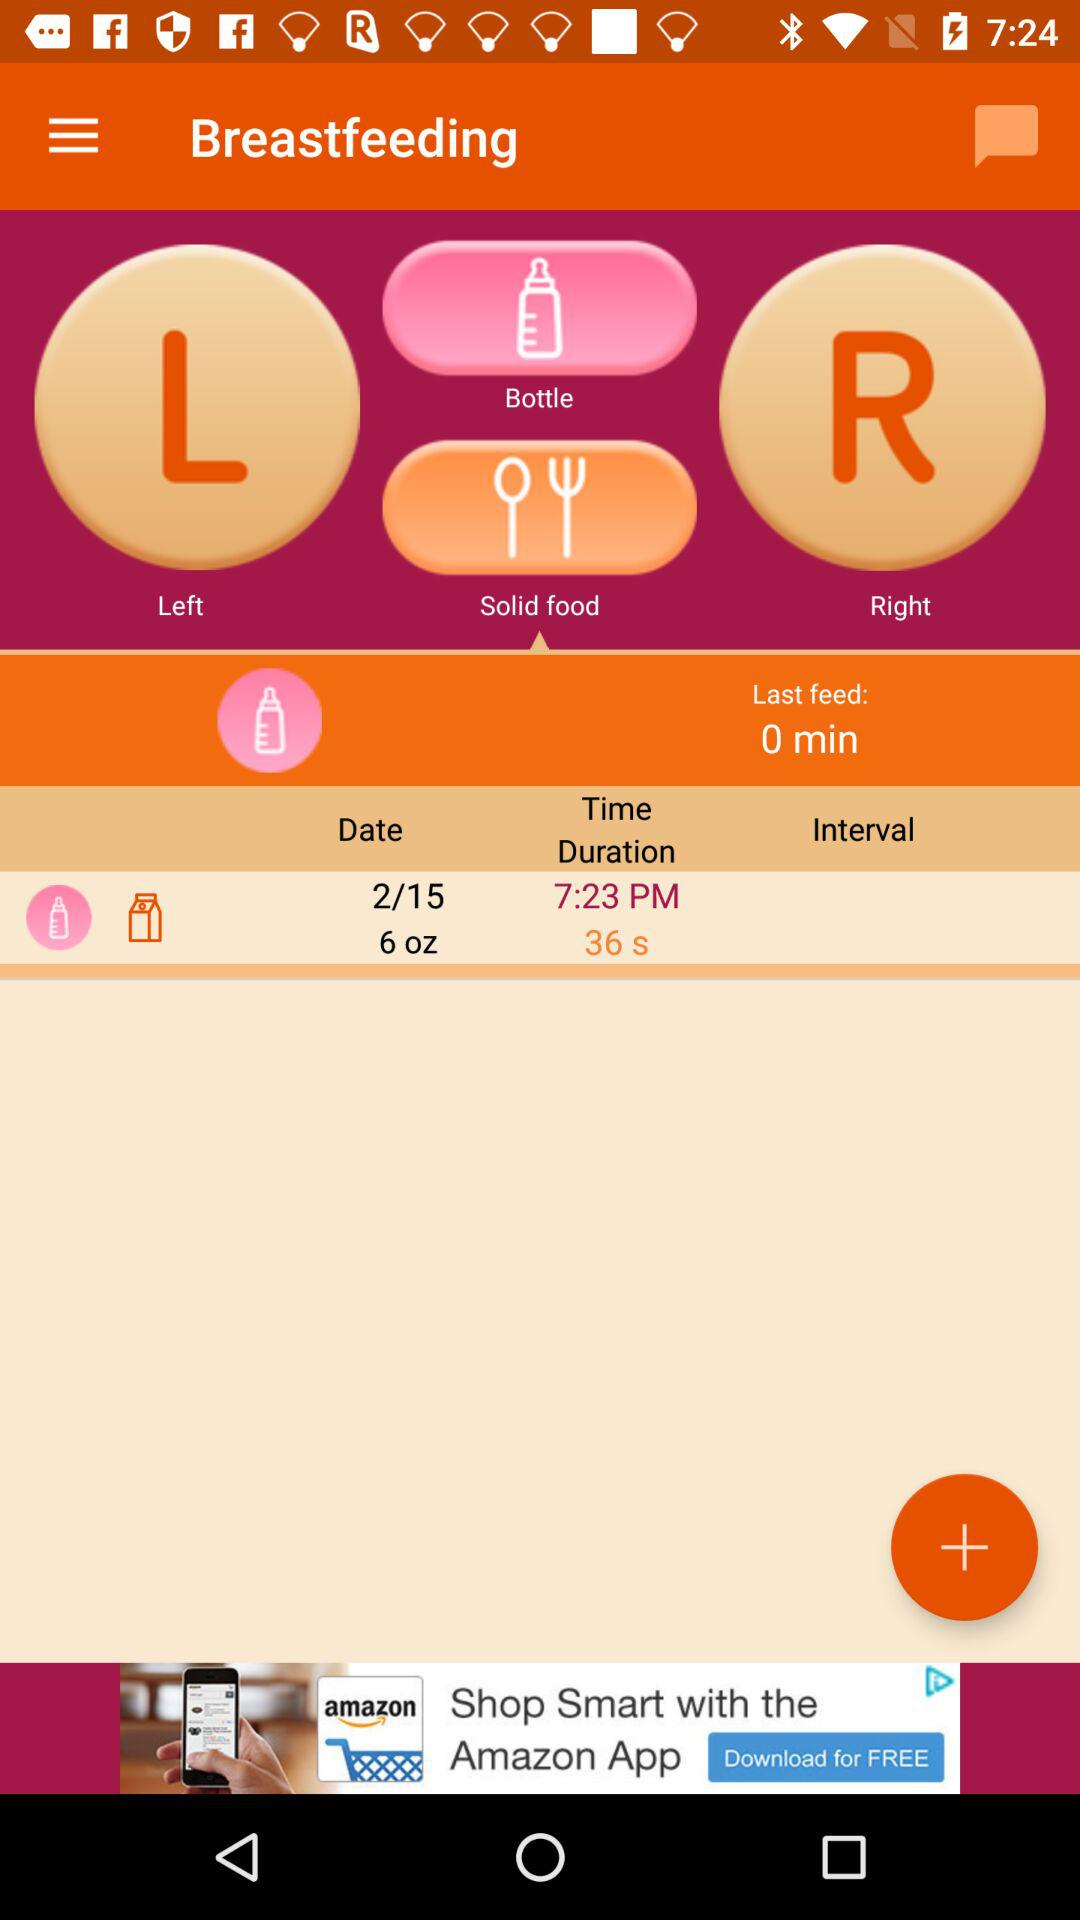What is the mentioned date? The mentioned date is February 15. 